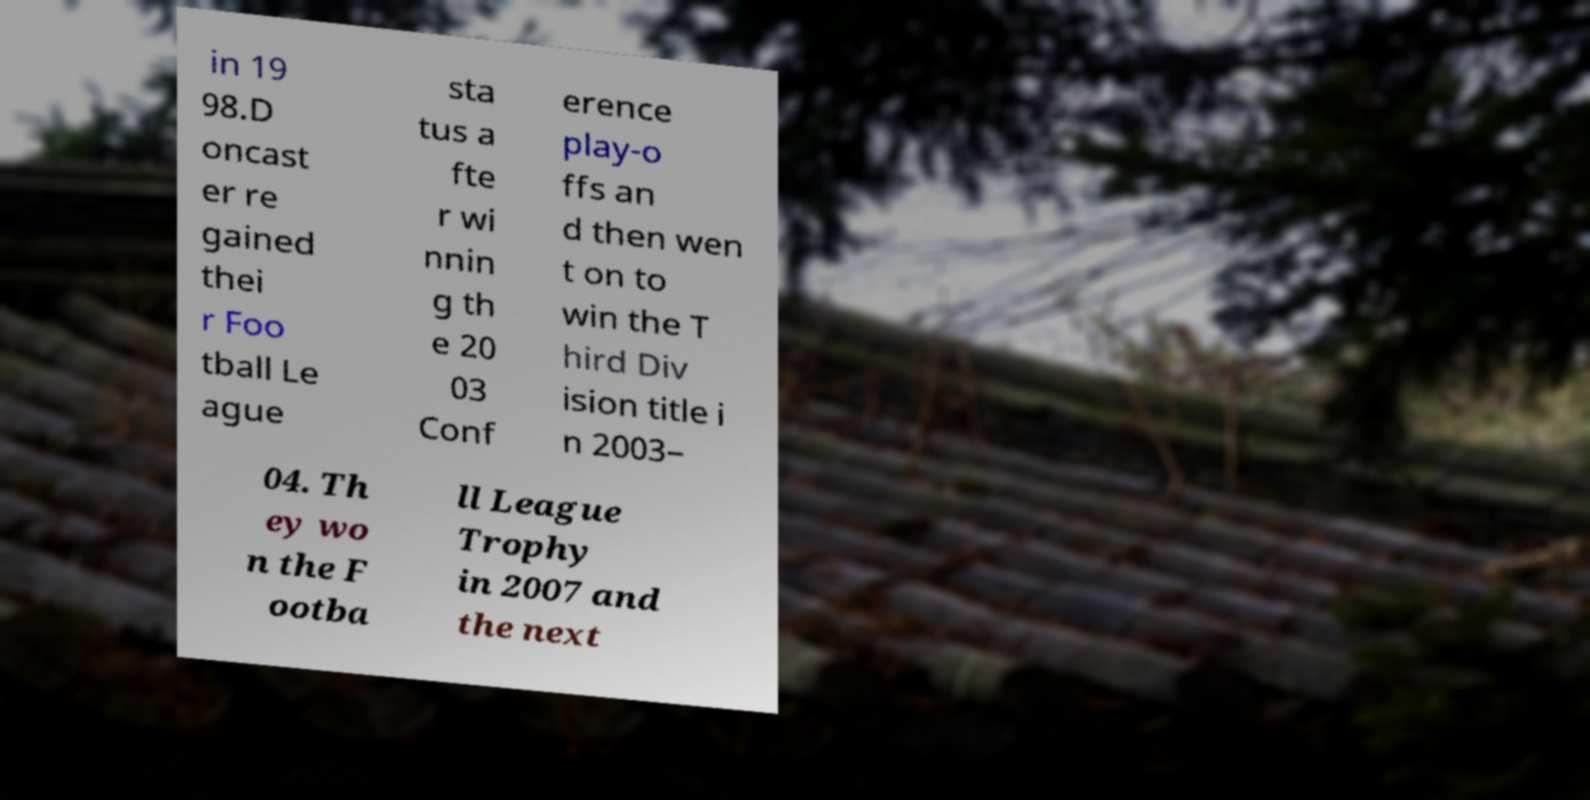Please identify and transcribe the text found in this image. in 19 98.D oncast er re gained thei r Foo tball Le ague sta tus a fte r wi nnin g th e 20 03 Conf erence play-o ffs an d then wen t on to win the T hird Div ision title i n 2003– 04. Th ey wo n the F ootba ll League Trophy in 2007 and the next 